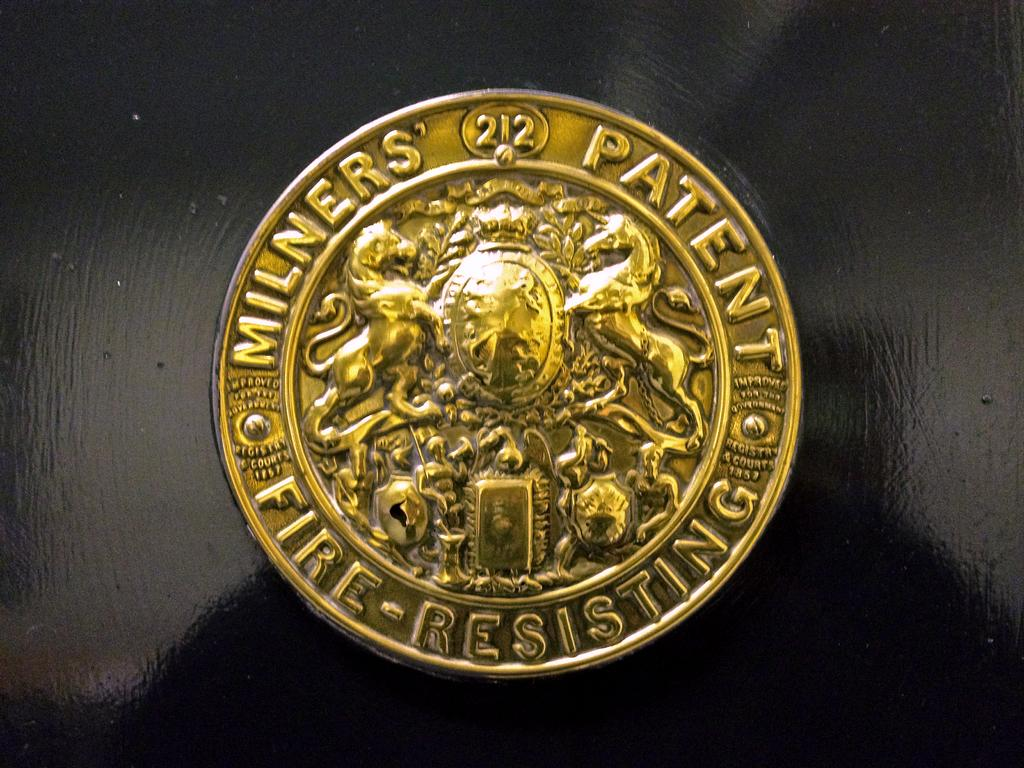<image>
Give a short and clear explanation of the subsequent image. An emblem that reads Milners' Patent Fire-Resisting in gold 